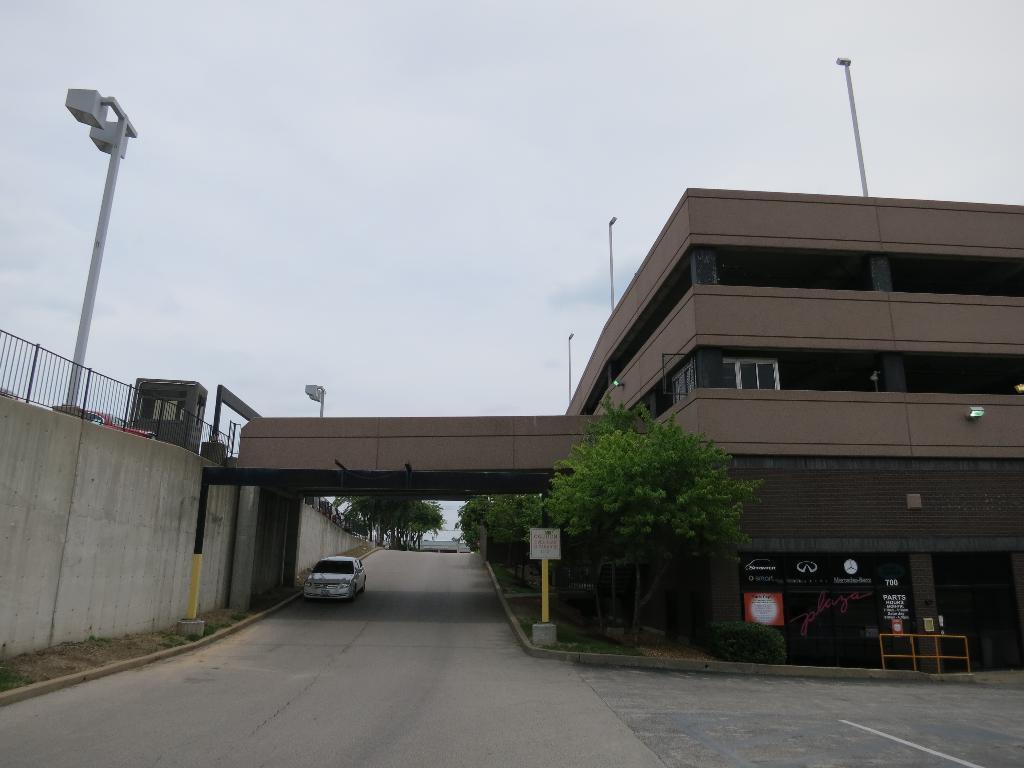Please provide a concise description of this image. In this image I can see the road. On the road there is a vehicle. To the side of the road there are boards and many trees. To the left I can see the bridge and building. In the background I can see the sky. 